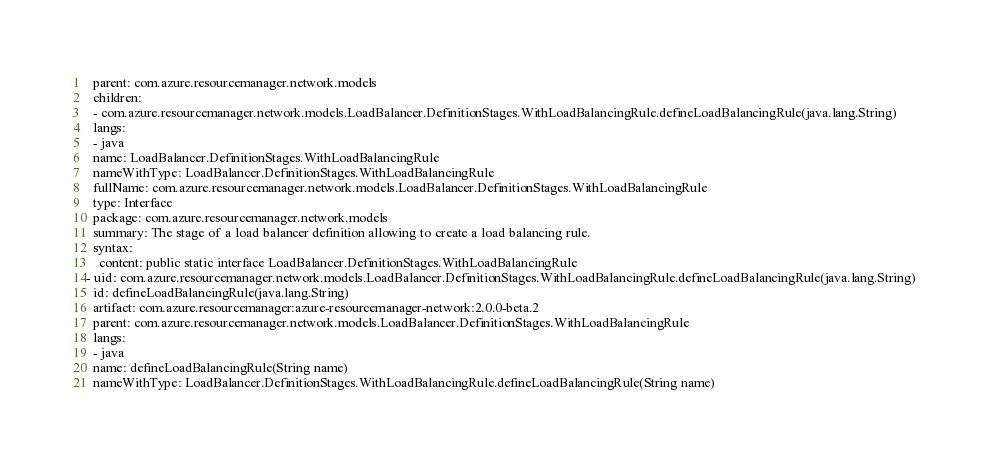<code> <loc_0><loc_0><loc_500><loc_500><_YAML_>  parent: com.azure.resourcemanager.network.models
  children:
  - com.azure.resourcemanager.network.models.LoadBalancer.DefinitionStages.WithLoadBalancingRule.defineLoadBalancingRule(java.lang.String)
  langs:
  - java
  name: LoadBalancer.DefinitionStages.WithLoadBalancingRule
  nameWithType: LoadBalancer.DefinitionStages.WithLoadBalancingRule
  fullName: com.azure.resourcemanager.network.models.LoadBalancer.DefinitionStages.WithLoadBalancingRule
  type: Interface
  package: com.azure.resourcemanager.network.models
  summary: The stage of a load balancer definition allowing to create a load balancing rule.
  syntax:
    content: public static interface LoadBalancer.DefinitionStages.WithLoadBalancingRule
- uid: com.azure.resourcemanager.network.models.LoadBalancer.DefinitionStages.WithLoadBalancingRule.defineLoadBalancingRule(java.lang.String)
  id: defineLoadBalancingRule(java.lang.String)
  artifact: com.azure.resourcemanager:azure-resourcemanager-network:2.0.0-beta.2
  parent: com.azure.resourcemanager.network.models.LoadBalancer.DefinitionStages.WithLoadBalancingRule
  langs:
  - java
  name: defineLoadBalancingRule(String name)
  nameWithType: LoadBalancer.DefinitionStages.WithLoadBalancingRule.defineLoadBalancingRule(String name)</code> 